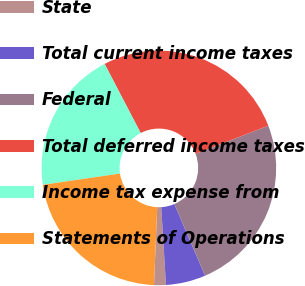<chart> <loc_0><loc_0><loc_500><loc_500><pie_chart><fcel>State<fcel>Total current income taxes<fcel>Federal<fcel>Total deferred income taxes<fcel>Income tax expense from<fcel>Statements of Operations<nl><fcel>1.63%<fcel>5.48%<fcel>24.41%<fcel>26.8%<fcel>19.65%<fcel>22.03%<nl></chart> 